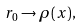Convert formula to latex. <formula><loc_0><loc_0><loc_500><loc_500>r _ { 0 } \to \rho ( x ) ,</formula> 